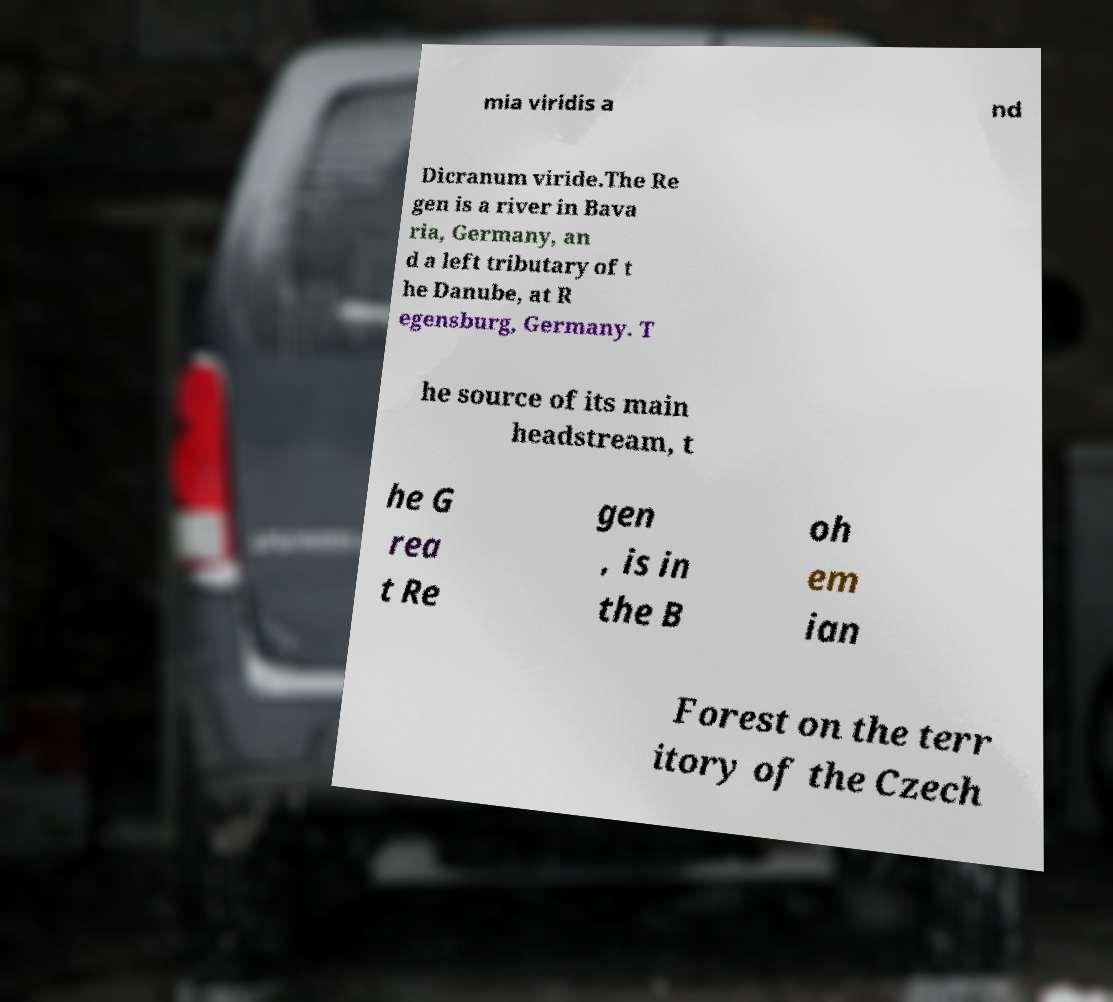Could you assist in decoding the text presented in this image and type it out clearly? mia viridis a nd Dicranum viride.The Re gen is a river in Bava ria, Germany, an d a left tributary of t he Danube, at R egensburg, Germany. T he source of its main headstream, t he G rea t Re gen , is in the B oh em ian Forest on the terr itory of the Czech 